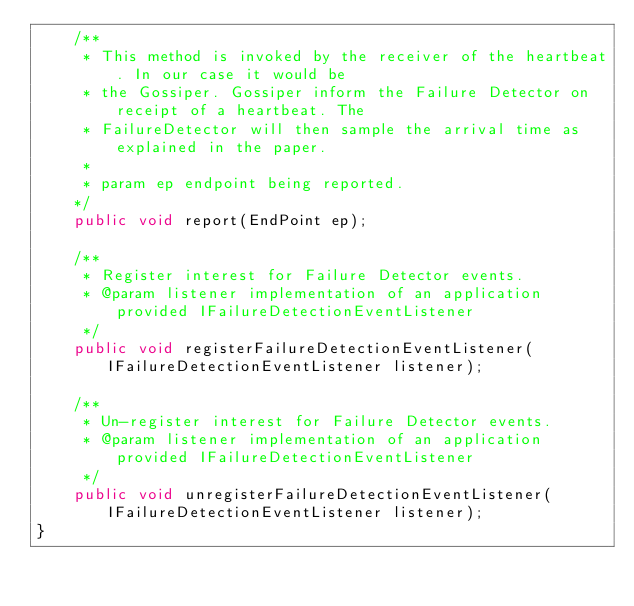<code> <loc_0><loc_0><loc_500><loc_500><_Java_>    /**
     * This method is invoked by the receiver of the heartbeat. In our case it would be
     * the Gossiper. Gossiper inform the Failure Detector on receipt of a heartbeat. The
     * FailureDetector will then sample the arrival time as explained in the paper.
     * 
     * param ep endpoint being reported.
    */
    public void report(EndPoint ep);
    
    /**
     * Register interest for Failure Detector events. 
     * @param listener implementation of an application provided IFailureDetectionEventListener 
     */
    public void registerFailureDetectionEventListener(IFailureDetectionEventListener listener);
    
    /**
     * Un-register interest for Failure Detector events. 
     * @param listener implementation of an application provided IFailureDetectionEventListener 
     */
    public void unregisterFailureDetectionEventListener(IFailureDetectionEventListener listener);
}
</code> 